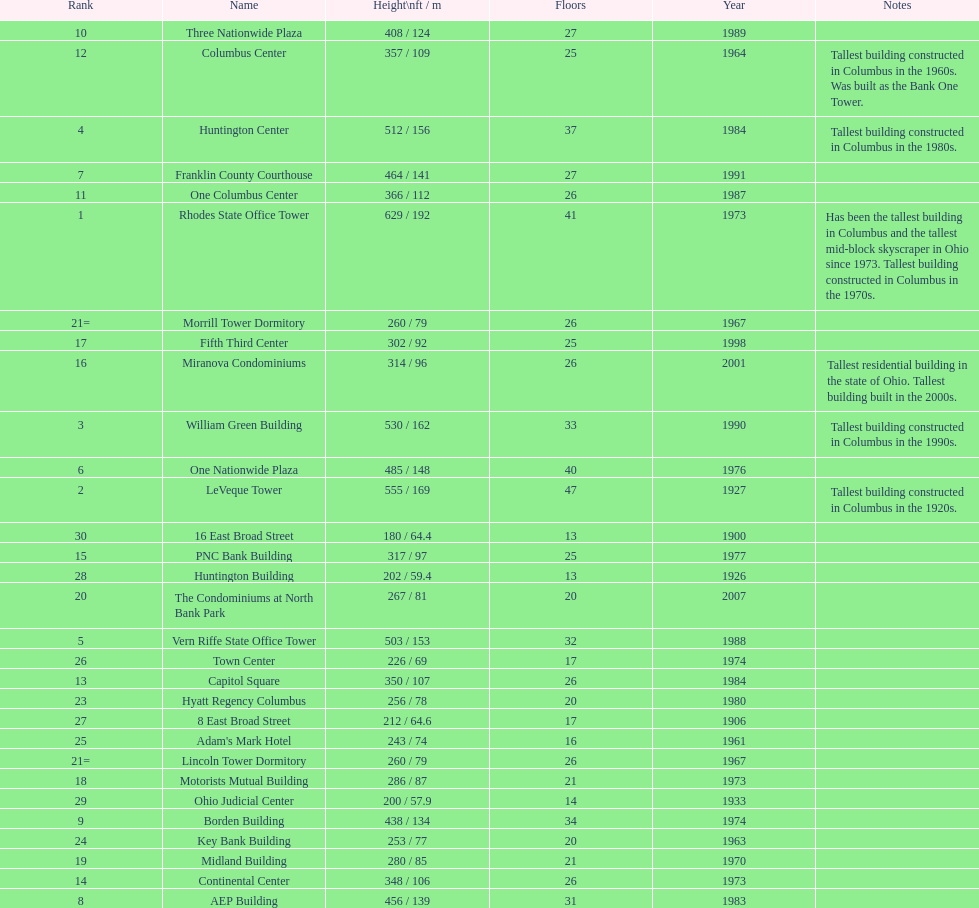How tall is the aep building? 456 / 139. How tall is the one columbus center? 366 / 112. Of these two buildings, which is taller? AEP Building. 